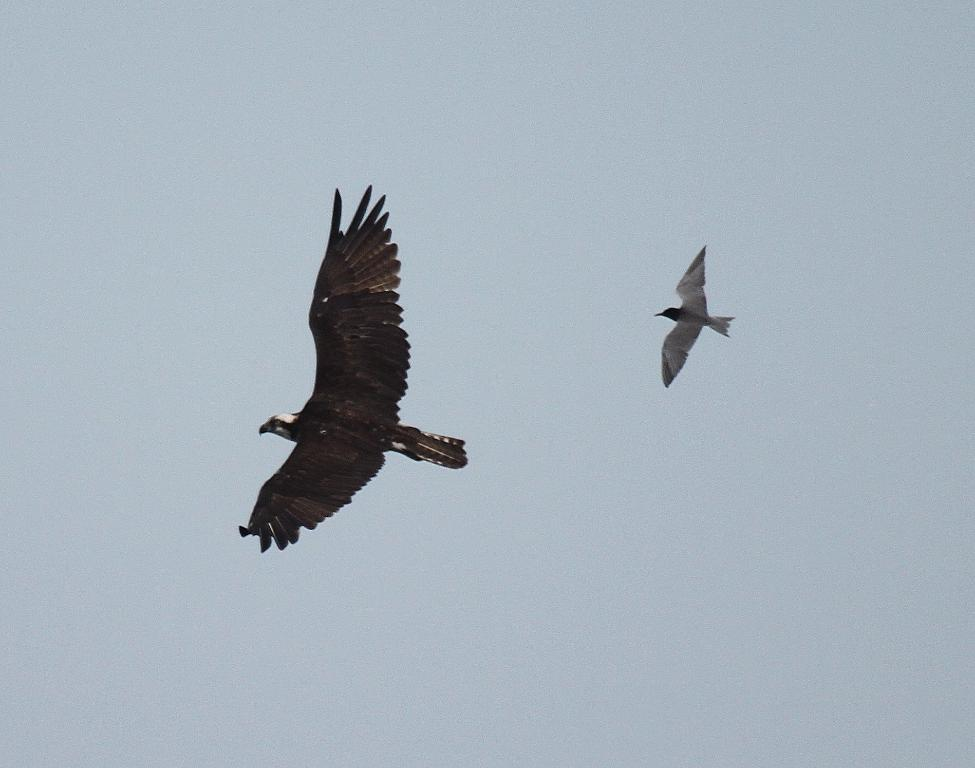How many birds are present in the image? There are 2 birds in the image. What are the birds doing in the image? The birds are in the air. What can be seen in the background of the image? The sky is visible in the background of the image. What is the cause of death for the bird with a long tail in the image? There is no bird with a long tail in the image, and no indication of death. 